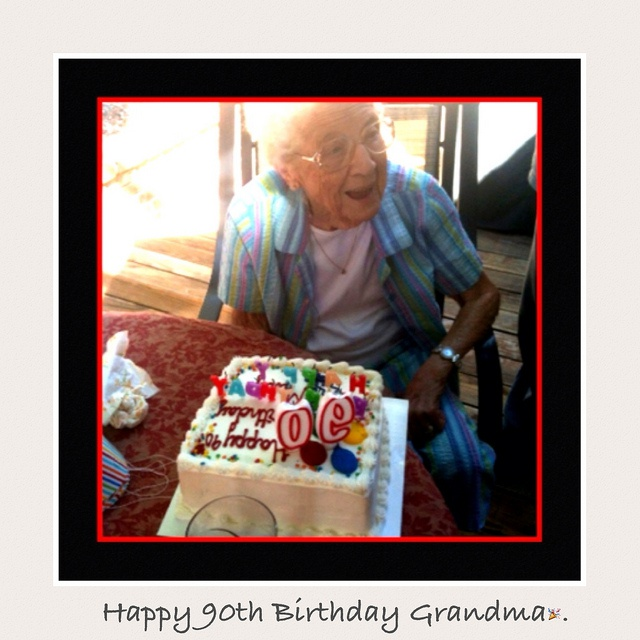Describe the objects in this image and their specific colors. I can see people in white, black, gray, and ivory tones, cake in white, tan, beige, darkgray, and brown tones, dining table in white, maroon, and brown tones, and chair in white, black, gray, and darkgray tones in this image. 